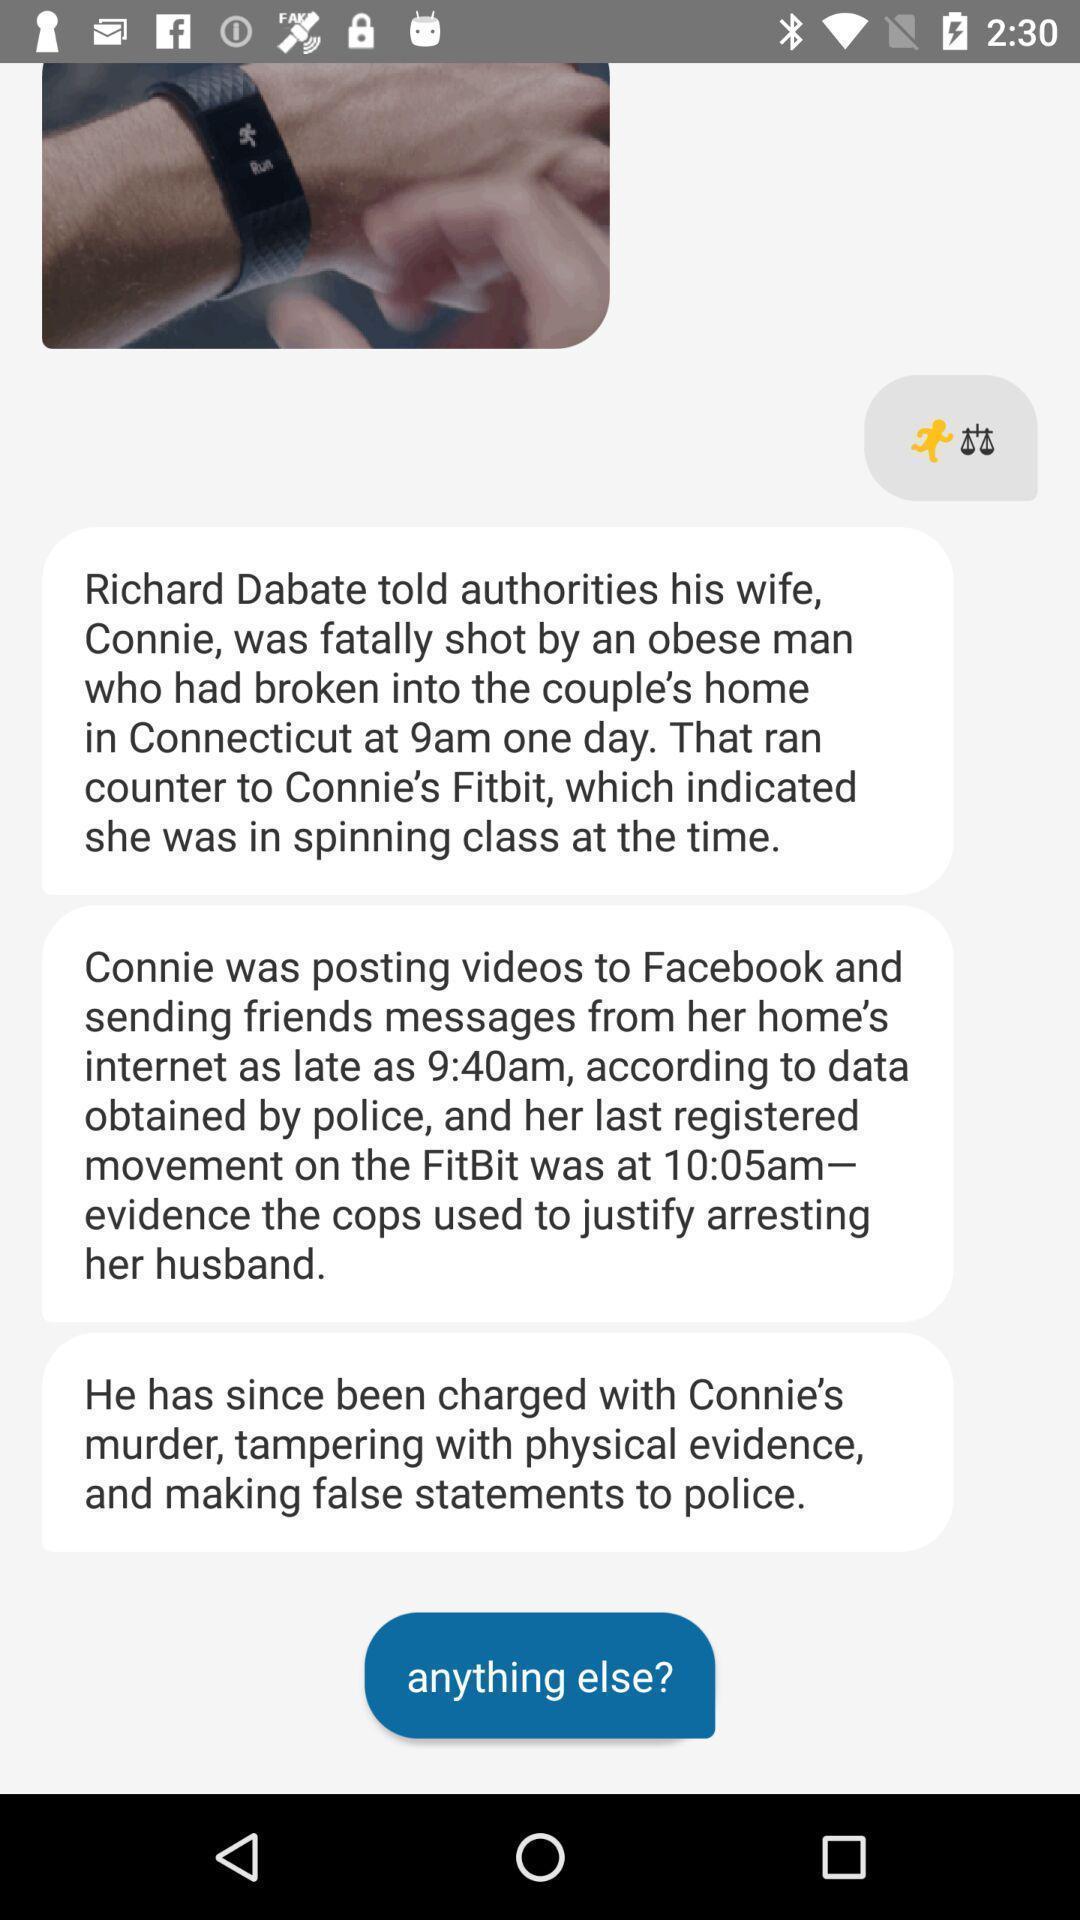Please provide a description for this image. Screen displaying the conversation page. 